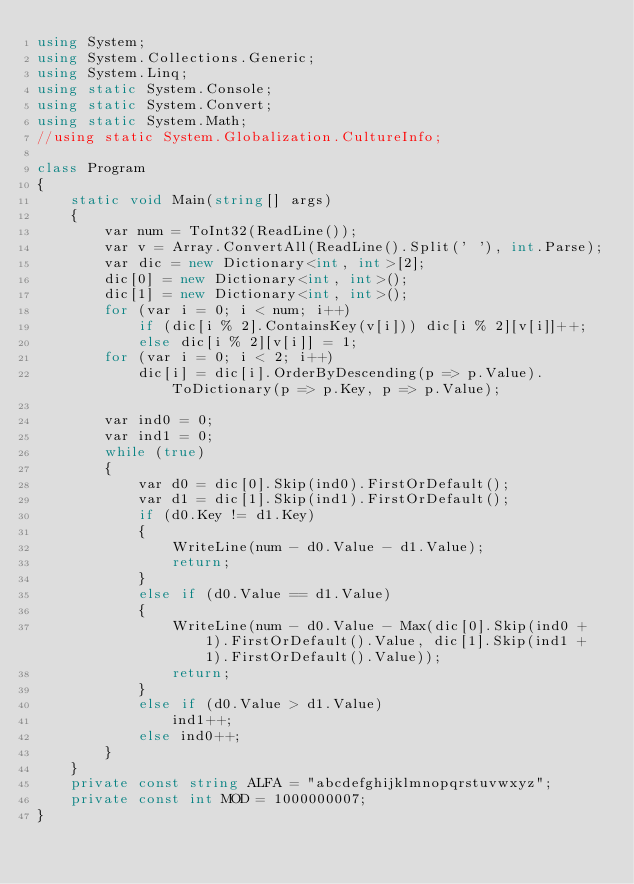<code> <loc_0><loc_0><loc_500><loc_500><_C#_>using System;
using System.Collections.Generic;
using System.Linq;
using static System.Console;
using static System.Convert;
using static System.Math;
//using static System.Globalization.CultureInfo;

class Program
{
    static void Main(string[] args)
    {
        var num = ToInt32(ReadLine());
        var v = Array.ConvertAll(ReadLine().Split(' '), int.Parse);
        var dic = new Dictionary<int, int>[2];
        dic[0] = new Dictionary<int, int>();
        dic[1] = new Dictionary<int, int>();
        for (var i = 0; i < num; i++)
            if (dic[i % 2].ContainsKey(v[i])) dic[i % 2][v[i]]++;
            else dic[i % 2][v[i]] = 1;
        for (var i = 0; i < 2; i++)
            dic[i] = dic[i].OrderByDescending(p => p.Value).ToDictionary(p => p.Key, p => p.Value);

        var ind0 = 0;
        var ind1 = 0;
        while (true)
        {
            var d0 = dic[0].Skip(ind0).FirstOrDefault();
            var d1 = dic[1].Skip(ind1).FirstOrDefault();
            if (d0.Key != d1.Key)
            {
                WriteLine(num - d0.Value - d1.Value);
                return;
            }
            else if (d0.Value == d1.Value)
            {
                WriteLine(num - d0.Value - Max(dic[0].Skip(ind0 + 1).FirstOrDefault().Value, dic[1].Skip(ind1 + 1).FirstOrDefault().Value));
                return;
            }
            else if (d0.Value > d1.Value)
                ind1++;
            else ind0++;
        }
    }
    private const string ALFA = "abcdefghijklmnopqrstuvwxyz";
    private const int MOD = 1000000007;
}</code> 